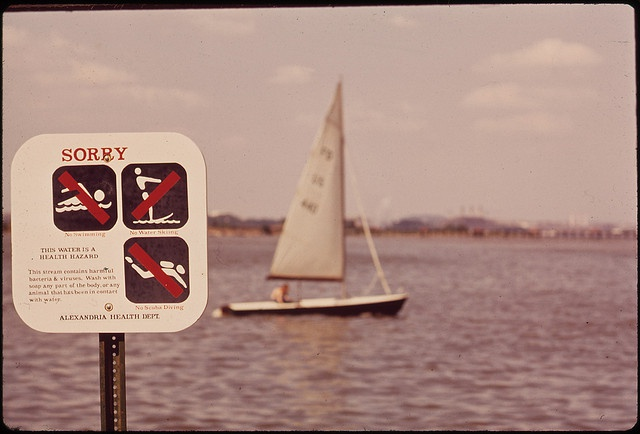Describe the objects in this image and their specific colors. I can see boat in black, tan, and gray tones and people in black, tan, and brown tones in this image. 